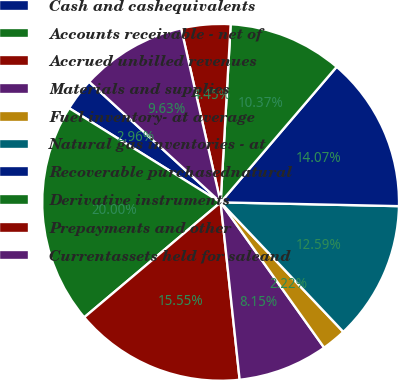<chart> <loc_0><loc_0><loc_500><loc_500><pie_chart><fcel>Cash and cashequivalents<fcel>Accounts receivable - net of<fcel>Accrued unbilled revenues<fcel>Materials and supplies<fcel>Fuel inventory- at average<fcel>Natural gas inventories - at<fcel>Recoverable purchasednatural<fcel>Derivative instruments<fcel>Prepayments and other<fcel>Currentassets held for saleand<nl><fcel>2.96%<fcel>20.0%<fcel>15.55%<fcel>8.15%<fcel>2.22%<fcel>12.59%<fcel>14.07%<fcel>10.37%<fcel>4.45%<fcel>9.63%<nl></chart> 